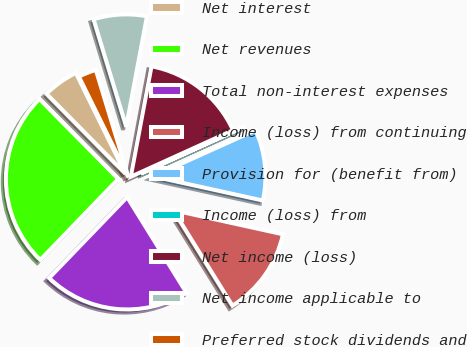<chart> <loc_0><loc_0><loc_500><loc_500><pie_chart><fcel>Net interest<fcel>Net revenues<fcel>Total non-interest expenses<fcel>Income (loss) from continuing<fcel>Provision for (benefit from)<fcel>Income (loss) from<fcel>Net income (loss)<fcel>Net income applicable to<fcel>Preferred stock dividends and<nl><fcel>5.12%<fcel>25.4%<fcel>21.04%<fcel>12.72%<fcel>10.19%<fcel>0.04%<fcel>15.26%<fcel>7.65%<fcel>2.58%<nl></chart> 